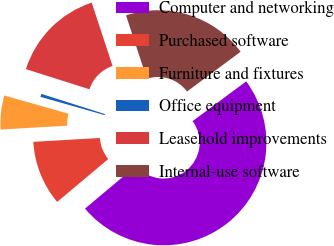Convert chart. <chart><loc_0><loc_0><loc_500><loc_500><pie_chart><fcel>Computer and networking<fcel>Purchased software<fcel>Furniture and fixtures<fcel>Office equipment<fcel>Leasehold improvements<fcel>Internal-use software<nl><fcel>49.05%<fcel>10.19%<fcel>5.33%<fcel>0.48%<fcel>15.05%<fcel>19.9%<nl></chart> 